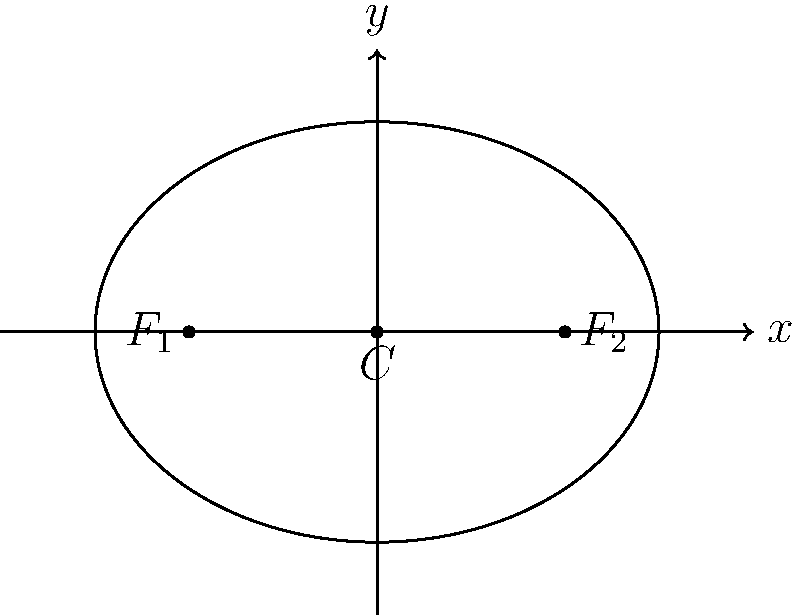As the celebrity press officer, you're tasked with determining the optimal focal point for a high-profile photoshoot. The setup area is modeled as an ellipse with foci at $(-2,0)$ and $(2,0)$, and a major axis length of 6 units. Calculate the distance from the center of the ellipse to either focus, which will be crucial for positioning the main lighting equipment. Express your answer in simplest radical form. Let's approach this step-by-step:

1) The equation of an ellipse is given by $\frac{x^2}{a^2} + \frac{y^2}{b^2} = 1$, where $a$ is the length of the semi-major axis and $b$ is the length of the semi-minor axis.

2) We're given that the foci are at $(-2,0)$ and $(2,0)$, so the center of the ellipse is at $(0,0)$.

3) The distance between the foci is 4 units.

4) The length of the major axis is 6 units, so $a = 3$ (half of the major axis).

5) In an ellipse, the relationship between $a$, $b$, and $c$ (the distance from the center to a focus) is given by $a^2 = b^2 + c^2$.

6) We need to find $c$. We know $a = 3$, and we can find $c$ using the distance formula:
   $c = \sqrt{(-2-0)^2 + (0-0)^2} = 2$

7) Now we can verify: $a^2 = 3^2 = 9$, and $c^2 = 2^2 = 4$

8) Therefore, $b^2 = a^2 - c^2 = 9 - 4 = 5$

9) So, $b = \sqrt{5}$

The distance from the center to either focus is $c = 2$.
Answer: 2 units 